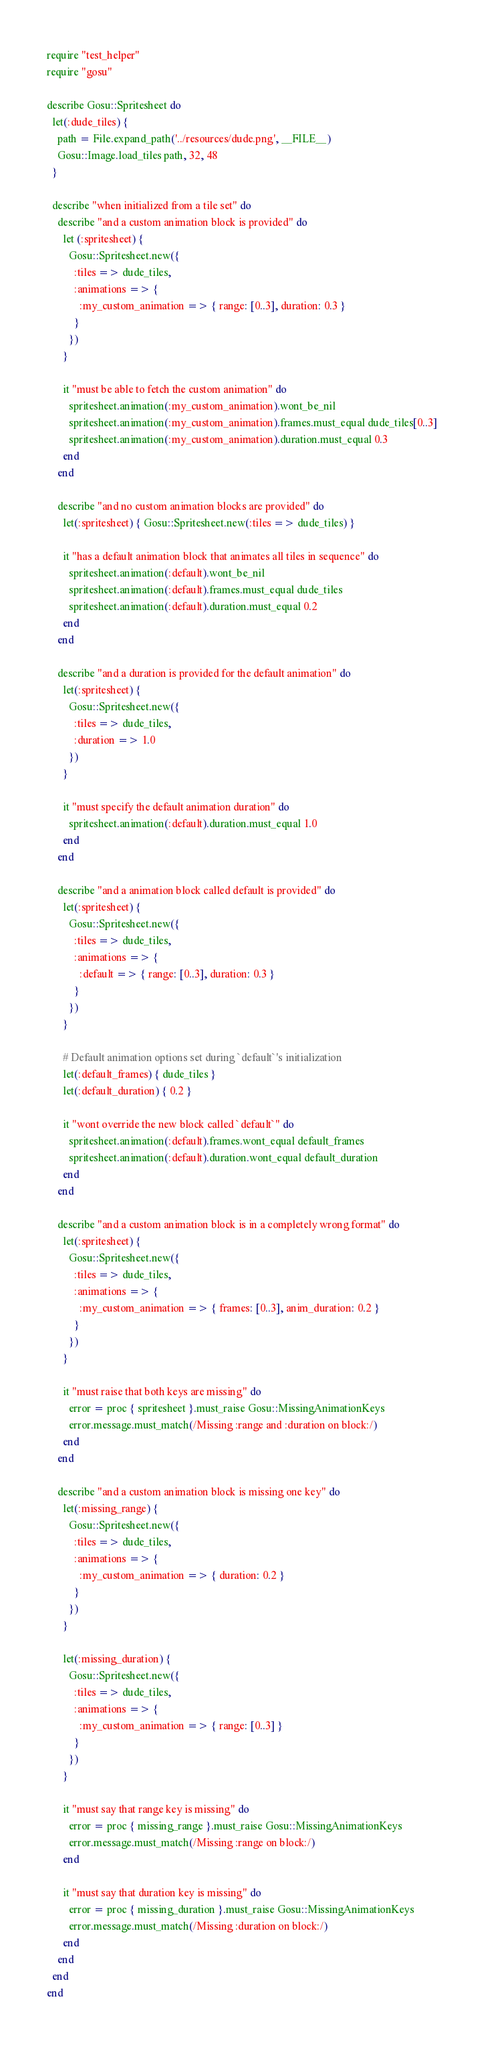<code> <loc_0><loc_0><loc_500><loc_500><_Ruby_>require "test_helper"
require "gosu"

describe Gosu::Spritesheet do
  let(:dude_tiles) { 
    path = File.expand_path('../resources/dude.png', __FILE__)
    Gosu::Image.load_tiles path, 32, 48 
  }
  
  describe "when initialized from a tile set" do
    describe "and a custom animation block is provided" do
      let (:spritesheet) {
        Gosu::Spritesheet.new({
          :tiles => dude_tiles,
          :animations => {
            :my_custom_animation => { range: [0..3], duration: 0.3 }
          }
        })
      }

      it "must be able to fetch the custom animation" do
        spritesheet.animation(:my_custom_animation).wont_be_nil
        spritesheet.animation(:my_custom_animation).frames.must_equal dude_tiles[0..3]
        spritesheet.animation(:my_custom_animation).duration.must_equal 0.3
      end
    end

    describe "and no custom animation blocks are provided" do
      let(:spritesheet) { Gosu::Spritesheet.new(:tiles => dude_tiles) }

      it "has a default animation block that animates all tiles in sequence" do
        spritesheet.animation(:default).wont_be_nil
        spritesheet.animation(:default).frames.must_equal dude_tiles
        spritesheet.animation(:default).duration.must_equal 0.2
      end
    end

    describe "and a duration is provided for the default animation" do
      let(:spritesheet) {
        Gosu::Spritesheet.new({
          :tiles => dude_tiles,
          :duration => 1.0
        })
      }

      it "must specify the default animation duration" do
        spritesheet.animation(:default).duration.must_equal 1.0
      end
    end
    
    describe "and a animation block called default is provided" do
      let(:spritesheet) { 
        Gosu::Spritesheet.new({
          :tiles => dude_tiles,
          :animations => {
            :default => { range: [0..3], duration: 0.3 }
          }
        })
      }

      # Default animation options set during `default`'s initialization
      let(:default_frames) { dude_tiles }
      let(:default_duration) { 0.2 }

      it "wont override the new block called `default`" do
        spritesheet.animation(:default).frames.wont_equal default_frames
        spritesheet.animation(:default).duration.wont_equal default_duration
      end
    end

    describe "and a custom animation block is in a completely wrong format" do
      let(:spritesheet) {
        Gosu::Spritesheet.new({
          :tiles => dude_tiles,
          :animations => {
            :my_custom_animation => { frames: [0..3], anim_duration: 0.2 }
          }
        })
      }

      it "must raise that both keys are missing" do
        error = proc { spritesheet }.must_raise Gosu::MissingAnimationKeys
        error.message.must_match(/Missing :range and :duration on block:/)
      end
    end

    describe "and a custom animation block is missing one key" do
      let(:missing_range) {
        Gosu::Spritesheet.new({
          :tiles => dude_tiles,
          :animations => {
            :my_custom_animation => { duration: 0.2 }
          }
        })
      }

      let(:missing_duration) {
        Gosu::Spritesheet.new({
          :tiles => dude_tiles,
          :animations => {
            :my_custom_animation => { range: [0..3] }
          }
        })
      }

      it "must say that range key is missing" do
        error = proc { missing_range }.must_raise Gosu::MissingAnimationKeys
        error.message.must_match(/Missing :range on block:/)
      end

      it "must say that duration key is missing" do
        error = proc { missing_duration }.must_raise Gosu::MissingAnimationKeys
        error.message.must_match(/Missing :duration on block:/)
      end
    end
  end
end
</code> 